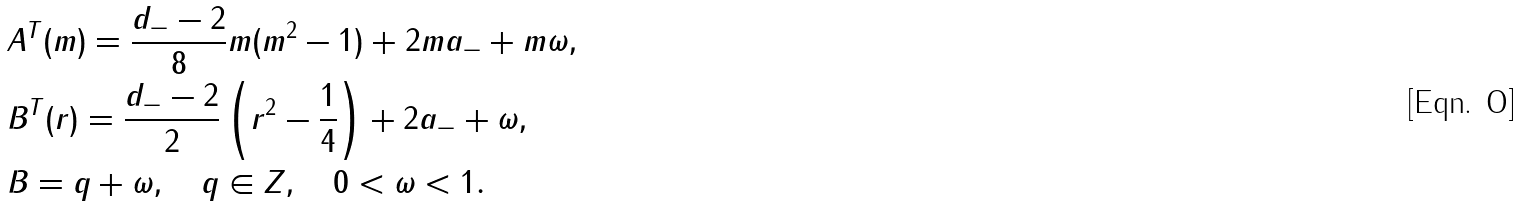Convert formula to latex. <formula><loc_0><loc_0><loc_500><loc_500>& A ^ { T } ( m ) = \frac { d _ { - } - 2 } { 8 } m ( m ^ { 2 } - 1 ) + 2 m a _ { - } + m \omega , \\ & B ^ { T } ( r ) = \frac { d _ { - } - 2 } { 2 } \left ( r ^ { 2 } - \frac { 1 } { 4 } \right ) + 2 a _ { - } + \omega , \\ & B = q + \omega , \quad q \in Z , \quad 0 < \omega < 1 .</formula> 